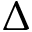Convert formula to latex. <formula><loc_0><loc_0><loc_500><loc_500>\Delta</formula> 